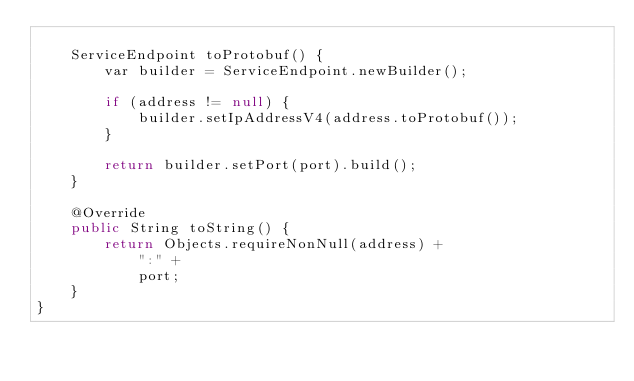Convert code to text. <code><loc_0><loc_0><loc_500><loc_500><_Java_>
    ServiceEndpoint toProtobuf() {
        var builder = ServiceEndpoint.newBuilder();

        if (address != null) {
            builder.setIpAddressV4(address.toProtobuf());
        }

        return builder.setPort(port).build();
    }

    @Override
    public String toString() {
        return Objects.requireNonNull(address) +
            ":" +
            port;
    }
}
</code> 